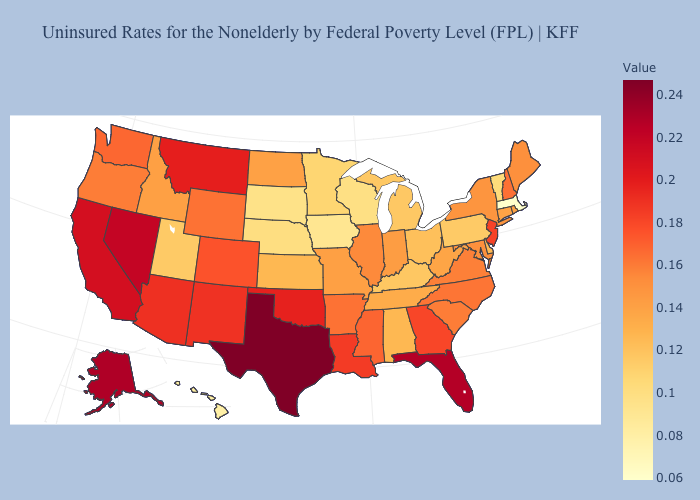Does South Dakota have the lowest value in the MidWest?
Keep it brief. No. Which states have the highest value in the USA?
Give a very brief answer. Texas. Which states have the highest value in the USA?
Quick response, please. Texas. Does Louisiana have a higher value than New Hampshire?
Be succinct. Yes. 